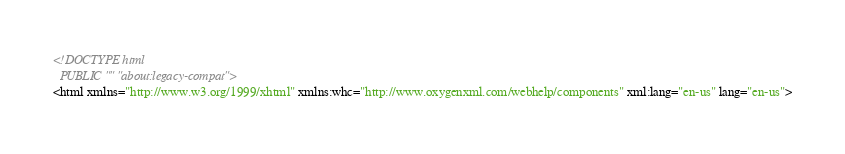<code> <loc_0><loc_0><loc_500><loc_500><_HTML_>
<!DOCTYPE html
  PUBLIC "" "about:legacy-compat">
<html xmlns="http://www.w3.org/1999/xhtml" xmlns:whc="http://www.oxygenxml.com/webhelp/components" xml:lang="en-us" lang="en-us"></code> 